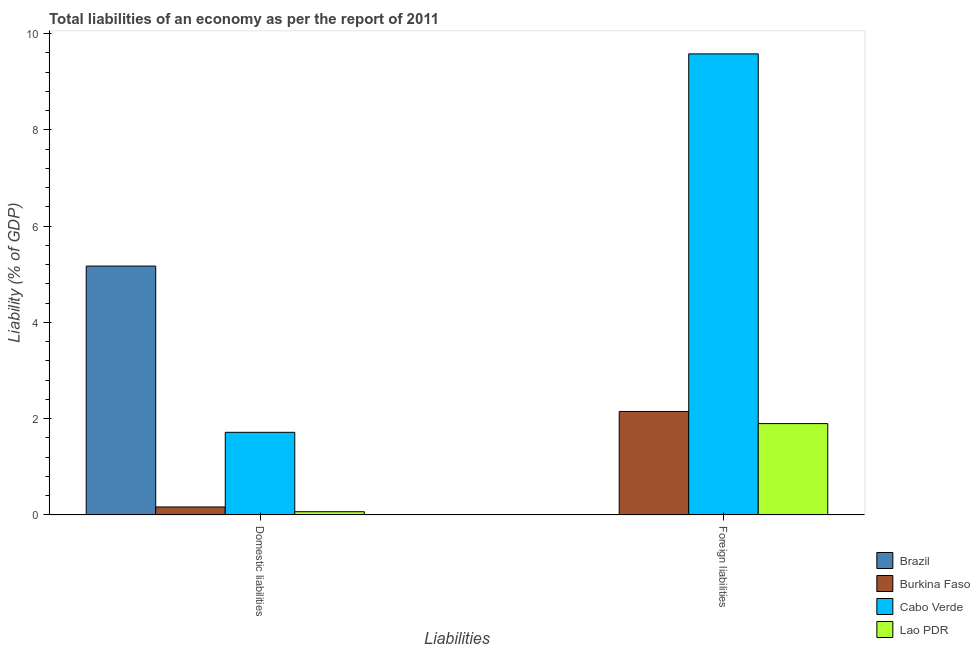How many different coloured bars are there?
Your response must be concise. 4. How many groups of bars are there?
Your answer should be very brief. 2. Are the number of bars per tick equal to the number of legend labels?
Your answer should be very brief. No. How many bars are there on the 1st tick from the right?
Keep it short and to the point. 3. What is the label of the 2nd group of bars from the left?
Ensure brevity in your answer.  Foreign liabilities. What is the incurrence of foreign liabilities in Lao PDR?
Offer a terse response. 1.9. Across all countries, what is the maximum incurrence of foreign liabilities?
Offer a very short reply. 9.58. Across all countries, what is the minimum incurrence of domestic liabilities?
Keep it short and to the point. 0.07. In which country was the incurrence of foreign liabilities maximum?
Ensure brevity in your answer.  Cabo Verde. What is the total incurrence of foreign liabilities in the graph?
Your answer should be compact. 13.63. What is the difference between the incurrence of domestic liabilities in Lao PDR and that in Cabo Verde?
Provide a succinct answer. -1.65. What is the difference between the incurrence of domestic liabilities in Burkina Faso and the incurrence of foreign liabilities in Lao PDR?
Your answer should be compact. -1.73. What is the average incurrence of foreign liabilities per country?
Give a very brief answer. 3.41. What is the difference between the incurrence of foreign liabilities and incurrence of domestic liabilities in Lao PDR?
Offer a very short reply. 1.83. In how many countries, is the incurrence of domestic liabilities greater than 8.4 %?
Your response must be concise. 0. What is the ratio of the incurrence of domestic liabilities in Burkina Faso to that in Brazil?
Your answer should be very brief. 0.03. In how many countries, is the incurrence of foreign liabilities greater than the average incurrence of foreign liabilities taken over all countries?
Keep it short and to the point. 1. How many bars are there?
Your answer should be compact. 7. Does the graph contain grids?
Make the answer very short. No. Where does the legend appear in the graph?
Offer a very short reply. Bottom right. What is the title of the graph?
Provide a short and direct response. Total liabilities of an economy as per the report of 2011. Does "Nicaragua" appear as one of the legend labels in the graph?
Give a very brief answer. No. What is the label or title of the X-axis?
Keep it short and to the point. Liabilities. What is the label or title of the Y-axis?
Offer a terse response. Liability (% of GDP). What is the Liability (% of GDP) in Brazil in Domestic liabilities?
Your answer should be compact. 5.17. What is the Liability (% of GDP) of Burkina Faso in Domestic liabilities?
Your answer should be compact. 0.17. What is the Liability (% of GDP) in Cabo Verde in Domestic liabilities?
Your answer should be very brief. 1.72. What is the Liability (% of GDP) of Lao PDR in Domestic liabilities?
Provide a short and direct response. 0.07. What is the Liability (% of GDP) in Burkina Faso in Foreign liabilities?
Give a very brief answer. 2.15. What is the Liability (% of GDP) in Cabo Verde in Foreign liabilities?
Provide a short and direct response. 9.58. What is the Liability (% of GDP) of Lao PDR in Foreign liabilities?
Your response must be concise. 1.9. Across all Liabilities, what is the maximum Liability (% of GDP) of Brazil?
Your answer should be very brief. 5.17. Across all Liabilities, what is the maximum Liability (% of GDP) of Burkina Faso?
Your response must be concise. 2.15. Across all Liabilities, what is the maximum Liability (% of GDP) in Cabo Verde?
Offer a terse response. 9.58. Across all Liabilities, what is the maximum Liability (% of GDP) in Lao PDR?
Provide a succinct answer. 1.9. Across all Liabilities, what is the minimum Liability (% of GDP) in Brazil?
Keep it short and to the point. 0. Across all Liabilities, what is the minimum Liability (% of GDP) of Burkina Faso?
Offer a very short reply. 0.17. Across all Liabilities, what is the minimum Liability (% of GDP) of Cabo Verde?
Give a very brief answer. 1.72. Across all Liabilities, what is the minimum Liability (% of GDP) of Lao PDR?
Provide a succinct answer. 0.07. What is the total Liability (% of GDP) of Brazil in the graph?
Make the answer very short. 5.17. What is the total Liability (% of GDP) of Burkina Faso in the graph?
Give a very brief answer. 2.32. What is the total Liability (% of GDP) of Cabo Verde in the graph?
Your response must be concise. 11.3. What is the total Liability (% of GDP) of Lao PDR in the graph?
Your answer should be very brief. 1.96. What is the difference between the Liability (% of GDP) of Burkina Faso in Domestic liabilities and that in Foreign liabilities?
Offer a terse response. -1.98. What is the difference between the Liability (% of GDP) of Cabo Verde in Domestic liabilities and that in Foreign liabilities?
Your answer should be very brief. -7.86. What is the difference between the Liability (% of GDP) of Lao PDR in Domestic liabilities and that in Foreign liabilities?
Your answer should be compact. -1.83. What is the difference between the Liability (% of GDP) in Brazil in Domestic liabilities and the Liability (% of GDP) in Burkina Faso in Foreign liabilities?
Your response must be concise. 3.02. What is the difference between the Liability (% of GDP) of Brazil in Domestic liabilities and the Liability (% of GDP) of Cabo Verde in Foreign liabilities?
Ensure brevity in your answer.  -4.41. What is the difference between the Liability (% of GDP) in Brazil in Domestic liabilities and the Liability (% of GDP) in Lao PDR in Foreign liabilities?
Your response must be concise. 3.27. What is the difference between the Liability (% of GDP) in Burkina Faso in Domestic liabilities and the Liability (% of GDP) in Cabo Verde in Foreign liabilities?
Your answer should be compact. -9.41. What is the difference between the Liability (% of GDP) in Burkina Faso in Domestic liabilities and the Liability (% of GDP) in Lao PDR in Foreign liabilities?
Give a very brief answer. -1.73. What is the difference between the Liability (% of GDP) in Cabo Verde in Domestic liabilities and the Liability (% of GDP) in Lao PDR in Foreign liabilities?
Your answer should be compact. -0.18. What is the average Liability (% of GDP) in Brazil per Liabilities?
Your answer should be very brief. 2.59. What is the average Liability (% of GDP) in Burkina Faso per Liabilities?
Make the answer very short. 1.16. What is the average Liability (% of GDP) of Cabo Verde per Liabilities?
Provide a succinct answer. 5.65. What is the average Liability (% of GDP) in Lao PDR per Liabilities?
Give a very brief answer. 0.98. What is the difference between the Liability (% of GDP) in Brazil and Liability (% of GDP) in Burkina Faso in Domestic liabilities?
Ensure brevity in your answer.  5.01. What is the difference between the Liability (% of GDP) of Brazil and Liability (% of GDP) of Cabo Verde in Domestic liabilities?
Make the answer very short. 3.45. What is the difference between the Liability (% of GDP) of Brazil and Liability (% of GDP) of Lao PDR in Domestic liabilities?
Your response must be concise. 5.1. What is the difference between the Liability (% of GDP) in Burkina Faso and Liability (% of GDP) in Cabo Verde in Domestic liabilities?
Offer a terse response. -1.55. What is the difference between the Liability (% of GDP) of Burkina Faso and Liability (% of GDP) of Lao PDR in Domestic liabilities?
Your answer should be compact. 0.1. What is the difference between the Liability (% of GDP) in Cabo Verde and Liability (% of GDP) in Lao PDR in Domestic liabilities?
Ensure brevity in your answer.  1.65. What is the difference between the Liability (% of GDP) of Burkina Faso and Liability (% of GDP) of Cabo Verde in Foreign liabilities?
Offer a very short reply. -7.43. What is the difference between the Liability (% of GDP) of Burkina Faso and Liability (% of GDP) of Lao PDR in Foreign liabilities?
Your answer should be compact. 0.25. What is the difference between the Liability (% of GDP) of Cabo Verde and Liability (% of GDP) of Lao PDR in Foreign liabilities?
Your answer should be very brief. 7.68. What is the ratio of the Liability (% of GDP) in Burkina Faso in Domestic liabilities to that in Foreign liabilities?
Offer a terse response. 0.08. What is the ratio of the Liability (% of GDP) of Cabo Verde in Domestic liabilities to that in Foreign liabilities?
Your response must be concise. 0.18. What is the ratio of the Liability (% of GDP) of Lao PDR in Domestic liabilities to that in Foreign liabilities?
Give a very brief answer. 0.04. What is the difference between the highest and the second highest Liability (% of GDP) of Burkina Faso?
Provide a short and direct response. 1.98. What is the difference between the highest and the second highest Liability (% of GDP) of Cabo Verde?
Your answer should be very brief. 7.86. What is the difference between the highest and the second highest Liability (% of GDP) of Lao PDR?
Give a very brief answer. 1.83. What is the difference between the highest and the lowest Liability (% of GDP) in Brazil?
Provide a short and direct response. 5.17. What is the difference between the highest and the lowest Liability (% of GDP) of Burkina Faso?
Offer a very short reply. 1.98. What is the difference between the highest and the lowest Liability (% of GDP) of Cabo Verde?
Offer a terse response. 7.86. What is the difference between the highest and the lowest Liability (% of GDP) of Lao PDR?
Your answer should be very brief. 1.83. 